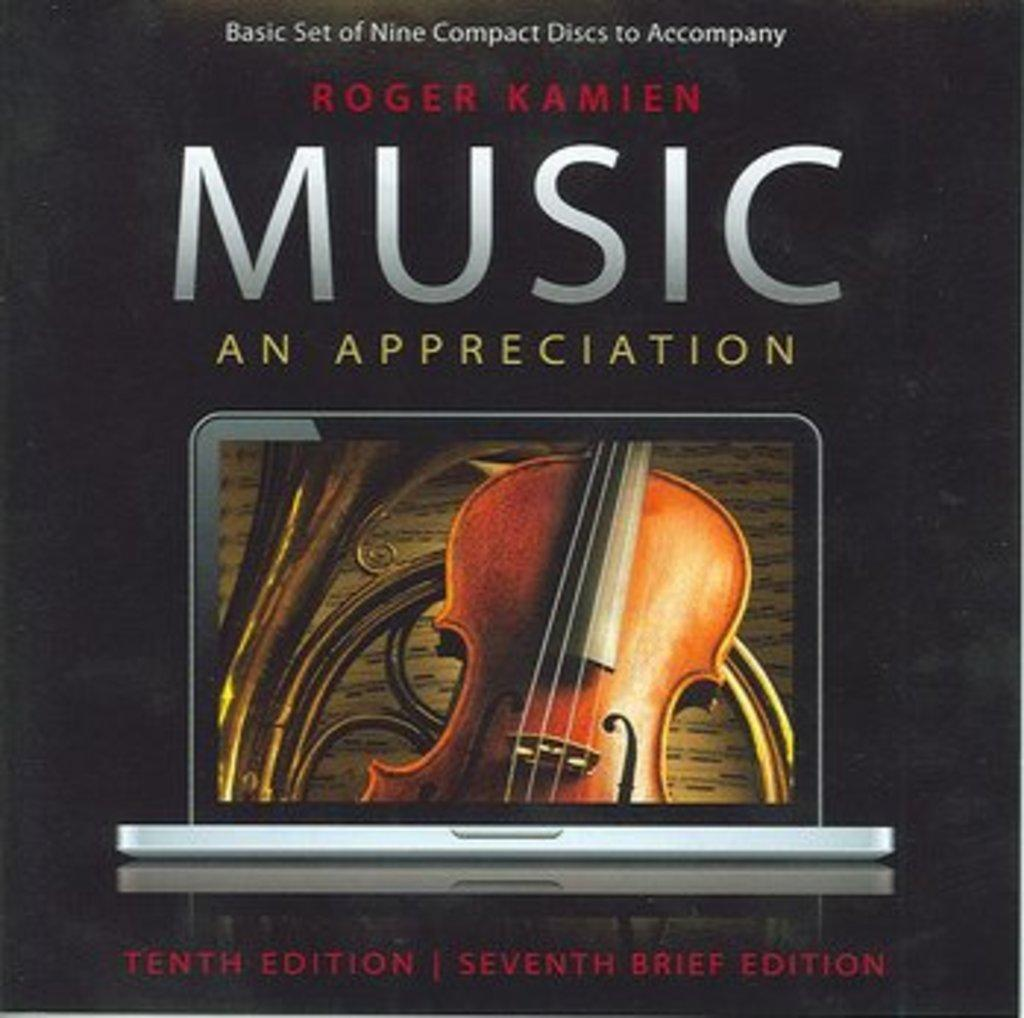Provide a one-sentence caption for the provided image. A cover reads Music an Appreciation and shows a violin. 